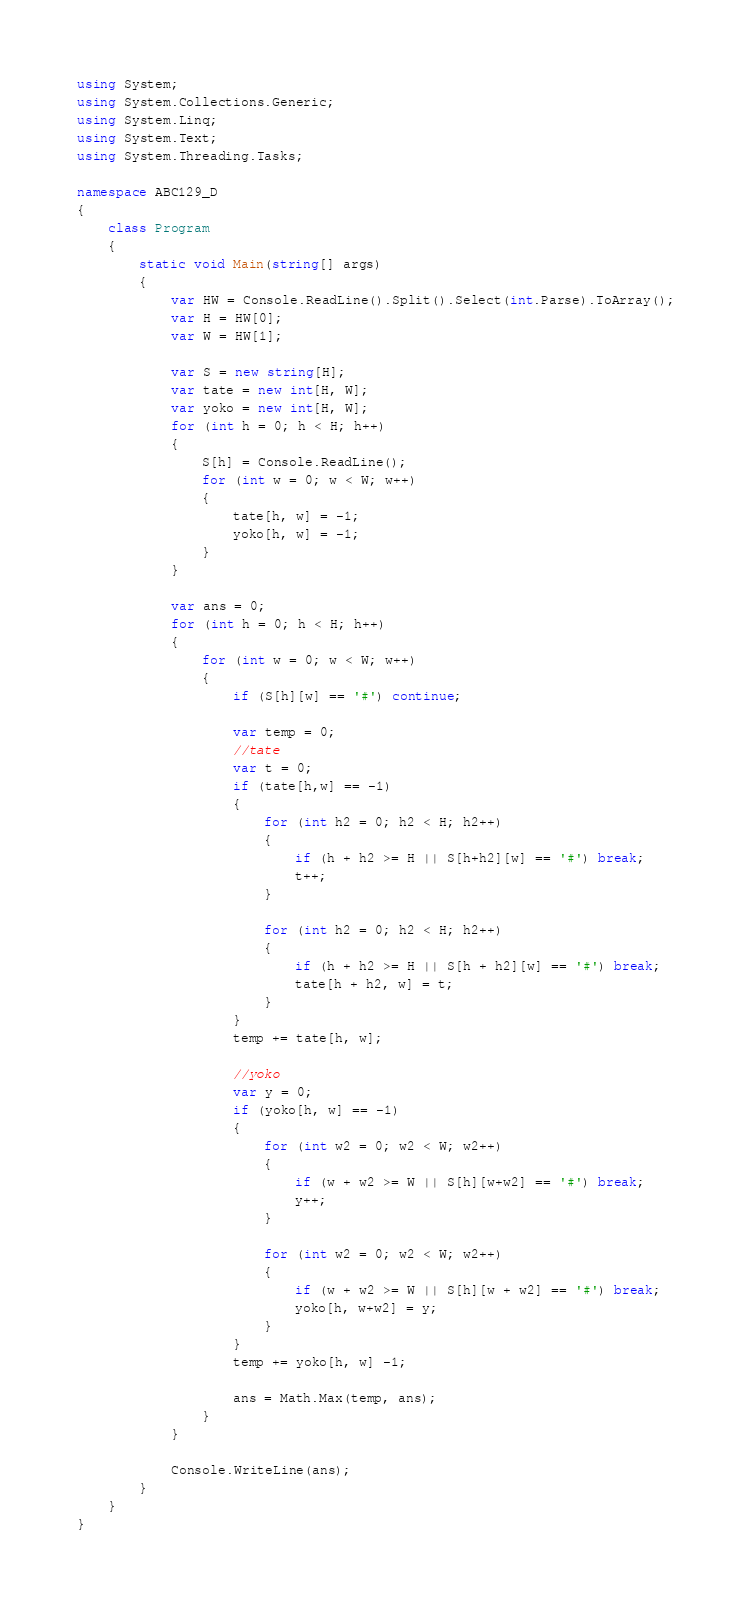<code> <loc_0><loc_0><loc_500><loc_500><_C#_>using System;
using System.Collections.Generic;
using System.Linq;
using System.Text;
using System.Threading.Tasks;

namespace ABC129_D
{
    class Program
    {
        static void Main(string[] args)
        {
            var HW = Console.ReadLine().Split().Select(int.Parse).ToArray();
            var H = HW[0];
            var W = HW[1];

            var S = new string[H];
            var tate = new int[H, W];
            var yoko = new int[H, W];
            for (int h = 0; h < H; h++)
            {
                S[h] = Console.ReadLine();
                for (int w = 0; w < W; w++)
                {
                    tate[h, w] = -1;
                    yoko[h, w] = -1;
                }
            }

            var ans = 0;
            for (int h = 0; h < H; h++)
            {
                for (int w = 0; w < W; w++)
                {
                    if (S[h][w] == '#') continue;

                    var temp = 0;
                    //tate
                    var t = 0;
                    if (tate[h,w] == -1)
                    {
                        for (int h2 = 0; h2 < H; h2++)
                        {
                            if (h + h2 >= H || S[h+h2][w] == '#') break;
                            t++;
                        }

                        for (int h2 = 0; h2 < H; h2++)
                        {
                            if (h + h2 >= H || S[h + h2][w] == '#') break;
                            tate[h + h2, w] = t;
                        }
                    }
                    temp += tate[h, w];

                    //yoko
                    var y = 0;
                    if (yoko[h, w] == -1)
                    {
                        for (int w2 = 0; w2 < W; w2++)
                        {
                            if (w + w2 >= W || S[h][w+w2] == '#') break;
                            y++;
                        }

                        for (int w2 = 0; w2 < W; w2++)
                        {
                            if (w + w2 >= W || S[h][w + w2] == '#') break;
                            yoko[h, w+w2] = y;
                        }
                    }
                    temp += yoko[h, w] -1;

                    ans = Math.Max(temp, ans);
                }
            }

            Console.WriteLine(ans);
        }
    }
}
</code> 